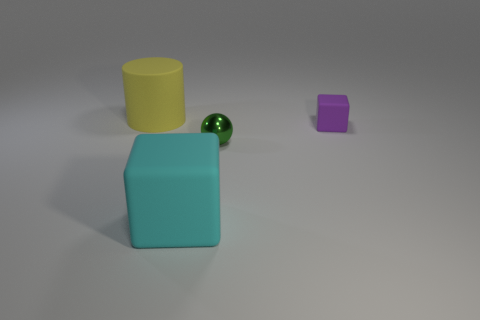There is a big object in front of the large matte object left of the rubber block that is left of the tiny purple matte object; what is its color?
Your response must be concise. Cyan. Does the purple rubber block have the same size as the thing that is on the left side of the large cyan cube?
Make the answer very short. No. What number of things are either big yellow matte balls or matte cubes?
Give a very brief answer. 2. Are there any large yellow cylinders that have the same material as the cyan object?
Make the answer very short. Yes. The big rubber thing to the left of the rubber object that is in front of the green shiny thing is what color?
Make the answer very short. Yellow. Do the yellow cylinder and the shiny object have the same size?
Keep it short and to the point. No. What number of blocks are either large yellow objects or tiny objects?
Your answer should be compact. 1. How many green spheres are to the left of the large rubber thing in front of the yellow thing?
Offer a terse response. 0. Does the large cyan object have the same shape as the green object?
Give a very brief answer. No. There is a purple rubber thing that is the same shape as the large cyan matte thing; what is its size?
Your response must be concise. Small. 